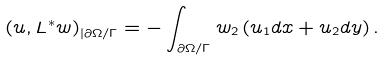Convert formula to latex. <formula><loc_0><loc_0><loc_500><loc_500>\left ( u , L ^ { \ast } w \right ) _ { | \partial \Omega / \Gamma } = - \int _ { \partial \Omega / \Gamma } w _ { 2 } \left ( u _ { 1 } d x + u _ { 2 } d y \right ) .</formula> 